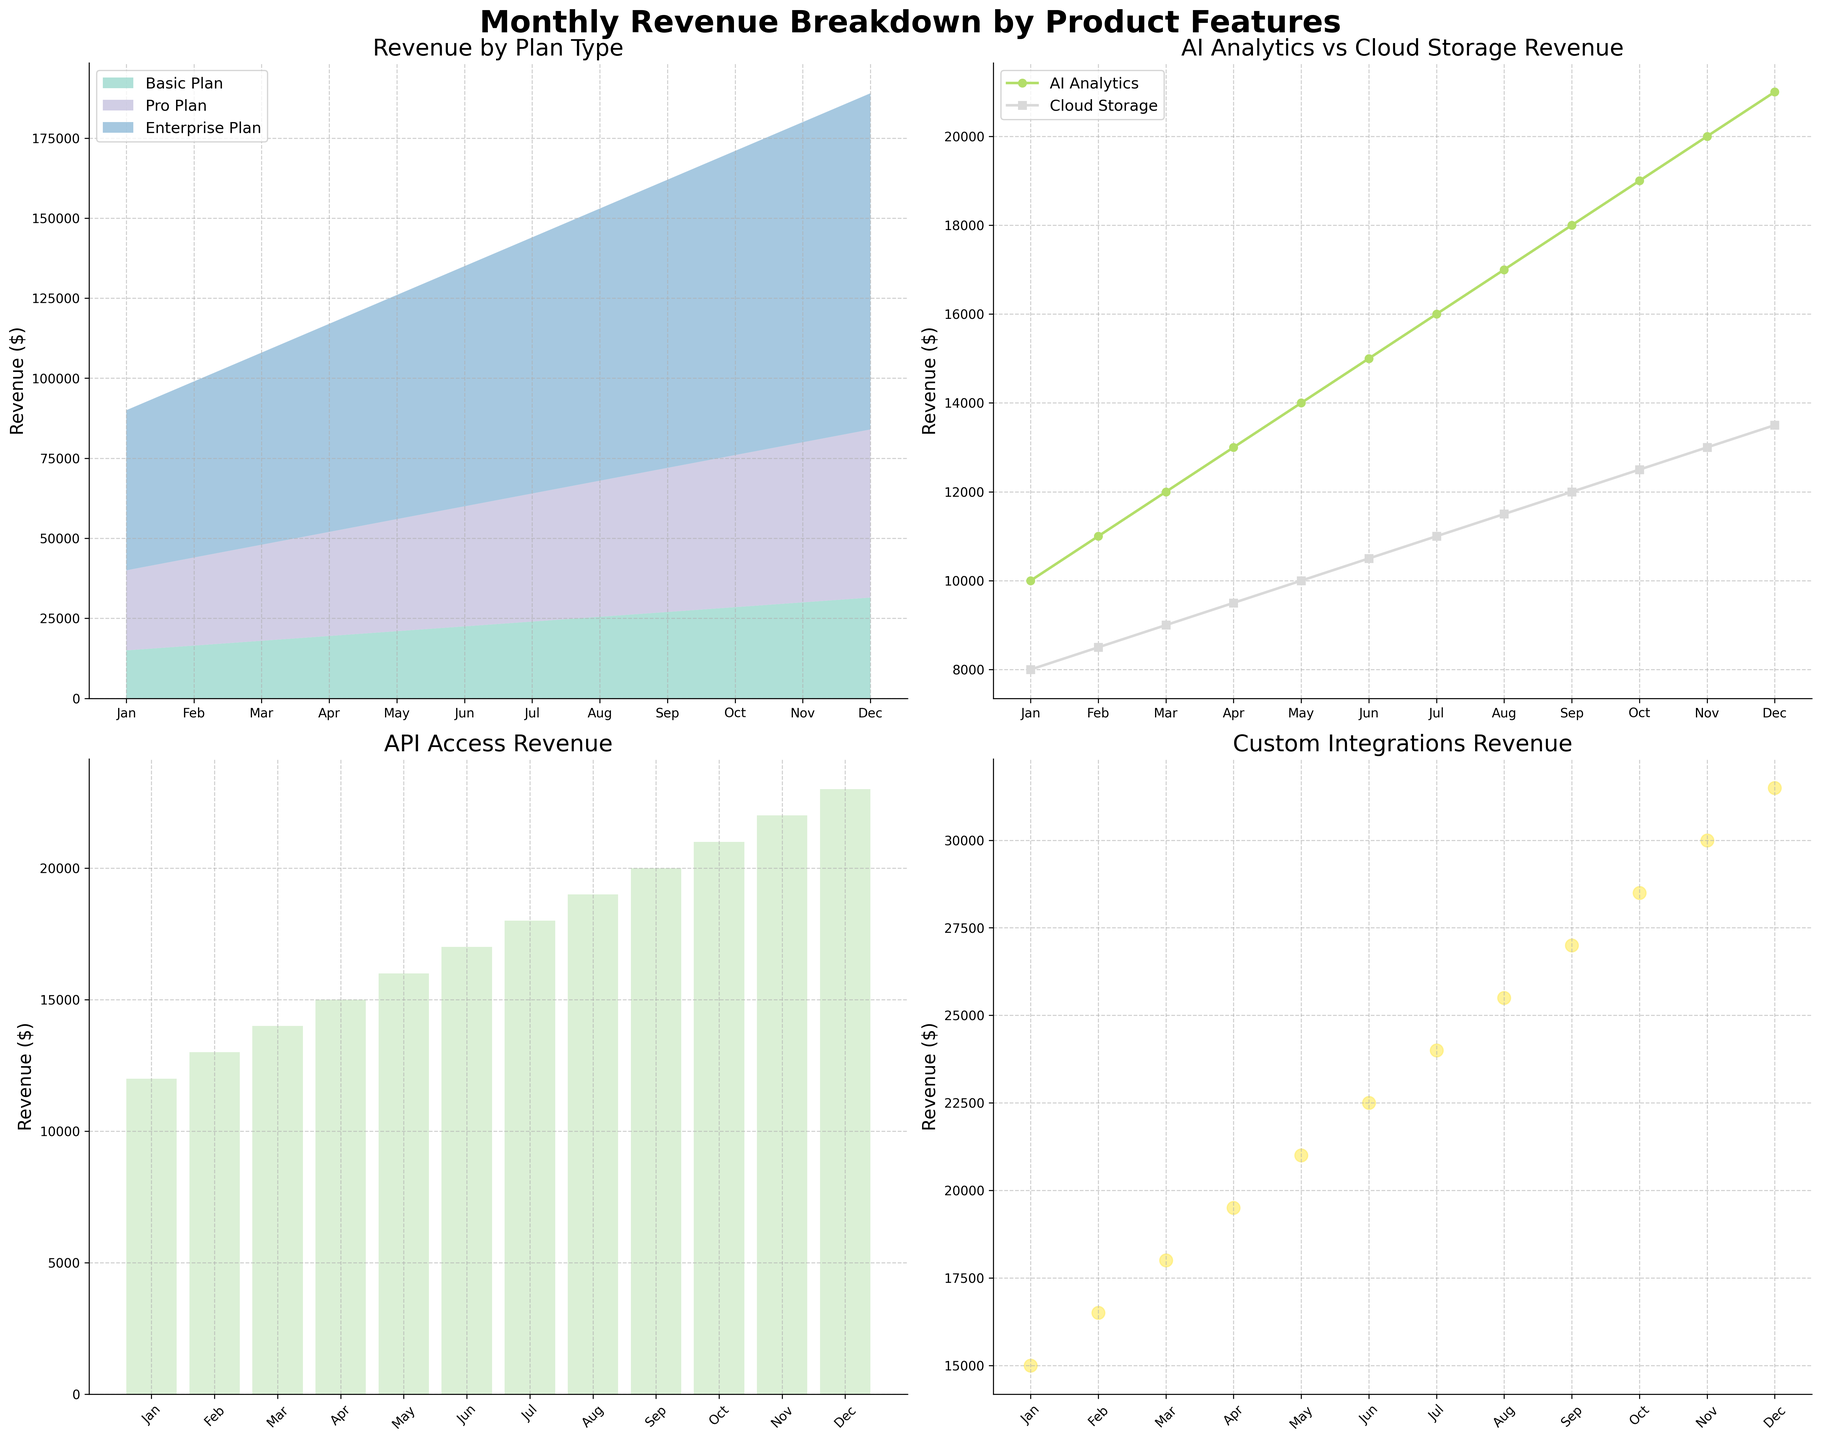Which feature had the highest revenue in January? In January, the 'Enterprise Plan' had the highest revenue among all features in the stacked area chart.
Answer: Enterprise Plan How much revenue did the 'Pro Plan' and 'Cloud Storage' generate in March combined? The 'Pro Plan' generated $30,000, and 'Cloud Storage' generated $9,000 in March. Combining these values gives $30,000 + $9,000 = $39,000.
Answer: $39,000 Compare the revenue trends of 'AI Analytics' and 'Cloud Storage' from January to December. Which one shows a consistent increase? Both 'AI Analytics' and 'Cloud Storage' show an upward trend. However, 'AI Analytics' shows a more consistent and linear increase compared to 'Cloud Storage'.
Answer: AI Analytics In the bar chart for 'API Access' revenue, which month showed the highest revenue? The bar chart indicates that December had the highest 'API Access' revenue with $23,000.
Answer: December What is the difference in revenue between 'Custom Integrations' and 'Basic Plan' in November? In November, 'Custom Integrations' generated $30,000, and 'Basic Plan' generated $30,000. The difference is $30,000 - $30,000 = $0.
Answer: $0 Which month showed the highest increase in revenue for the 'Enterprise Plan' compared to the previous month? The highest increase in revenue for the 'Enterprise Plan' compared to the previous month was in January to February, where it increased by $5,000.
Answer: February How does the total revenue trend for basic and pro plans compare against the enterprise plan from January to December? The stacked area chart shows that while both the 'Basic Plan' and 'Pro Plan' have a constant and moderate increase, the 'Enterprise Plan' has a much steeper increase, indicating a much higher rate of growth.
Answer: Enterprise Plan has steeper growth For 'AI Analytics', what is the percentage increase in revenue from January to December? 'AI Analytics' revenue in January was $10,000 and in December was $21,000. The percentage increase is calculated as ((21,000 - 10,000) / 10,000) * 100 = 110%.
Answer: 110% Is there a specific quarter where 'Custom Integrations' revenue grew faster than other quarters? By examining the scatter plot for 'Custom Integrations', Q3 (July to September) shows a notable increase from $24,000 to $27,000.
Answer: Q3 